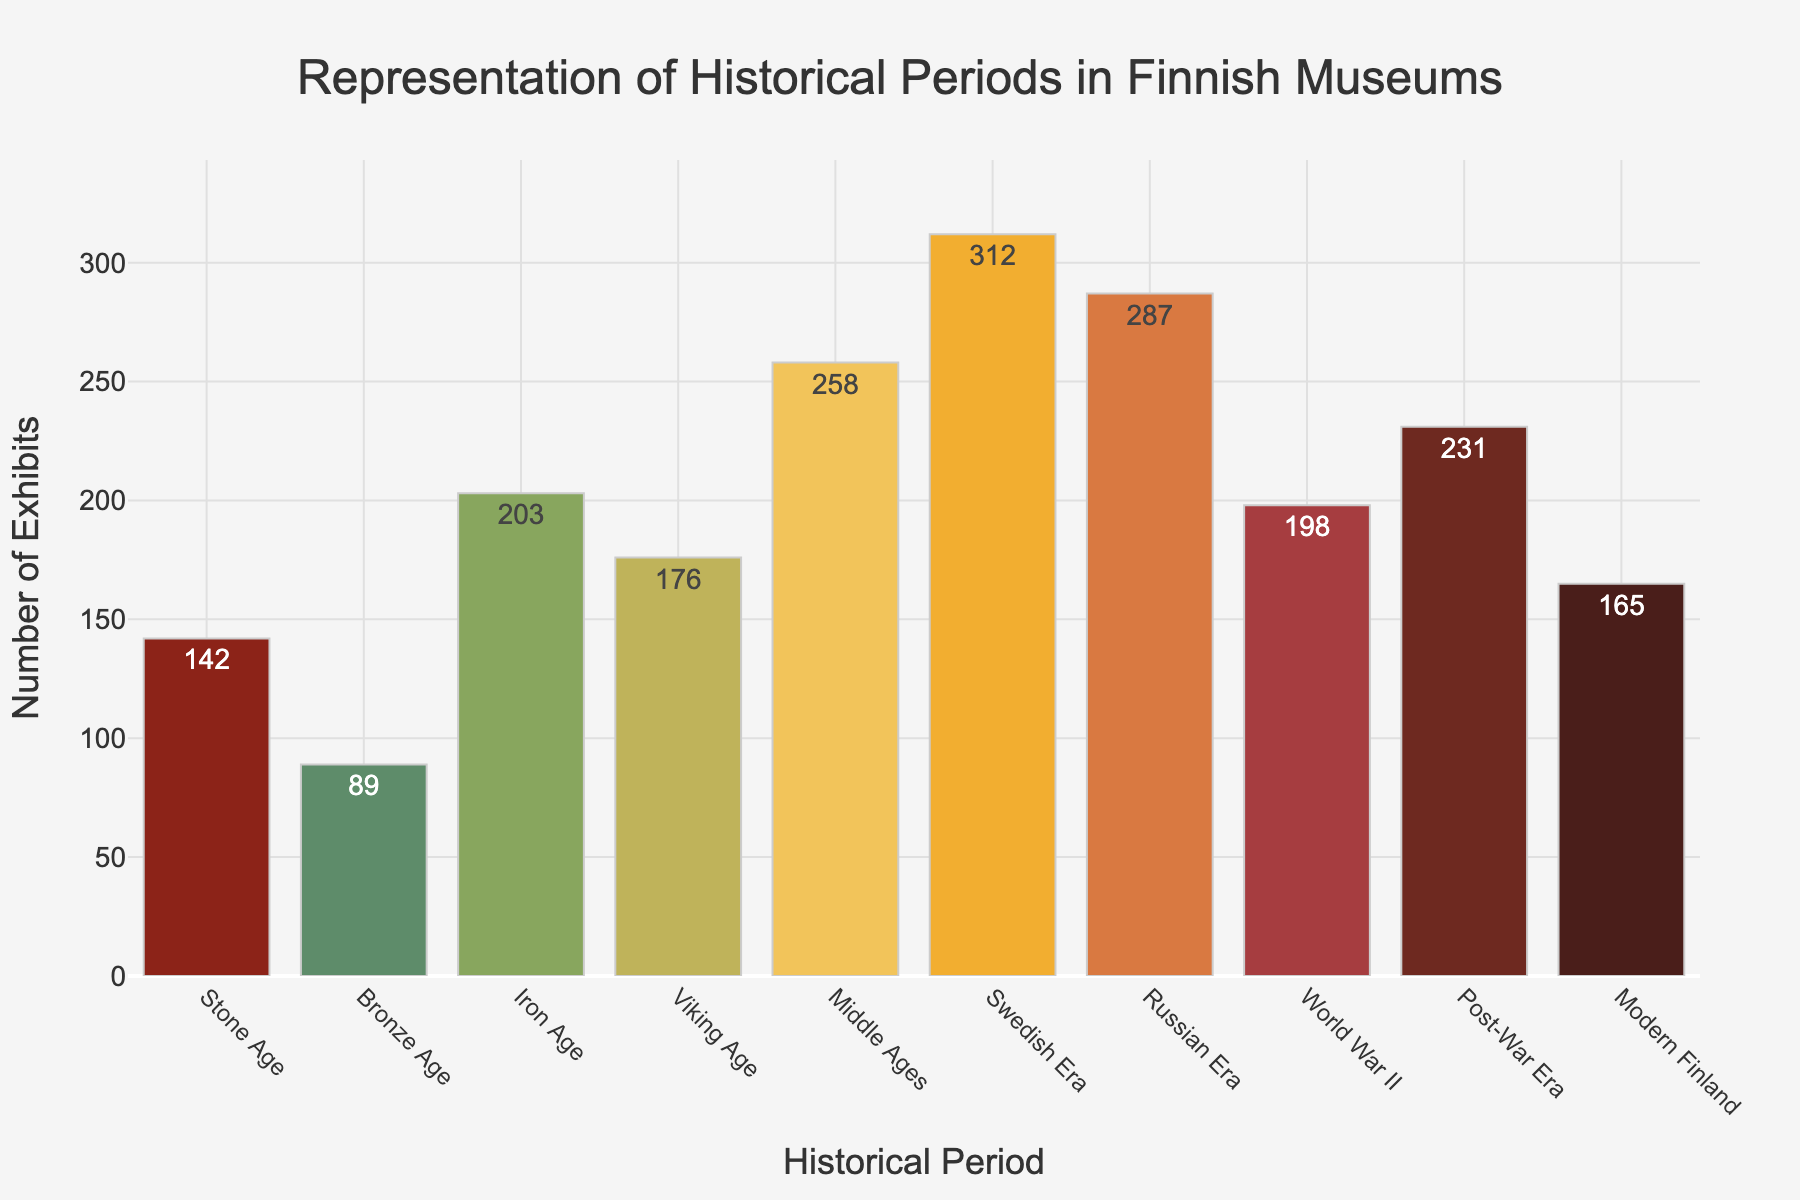Which historical period has the highest number of exhibits? The bar representing the Swedish Era is the tallest in the chart. The number of exhibits is 312.
Answer: Swedish Era Which historical period has the lowest number of exhibits? The bar representing the Bronze Age is the shortest in the chart. The number of exhibits is 89.
Answer: Bronze Age What is the combined number of exhibits from the Medieval Ages and the Viking Age? The number of exhibits for the Middle Ages is 258 and for the Viking Age is 176. Combined, it is 258 + 176 = 434.
Answer: 434 Which period has more exhibits, the Iron Age or Modern Finland? The bar for the Iron Age is taller than the bar for Modern Finland. Iron Age has 203 exhibits, and Modern Finland has 165.
Answer: Iron Age How many more exhibits are there in the Swedish Era compared to the Stone Age? The Swedish Era has 312 exhibits and the Stone Age has 142. The difference is 312 - 142 = 170.
Answer: 170 Which period, the Russian Era or Post-War Era, has a higher number of exhibits, and by how much? The bar for the Russian Era is taller than that for the Post-War Era. Russian Era has 287 exhibits and Post-War Era has 231. The difference is 287 - 231 = 56.
Answer: Russian Era by 56 What is the average number of exhibits across all periods? The total number of exhibits is 142 + 89 + 203 + 176 + 258 + 312 + 287 + 198 + 231 + 165 = 2061. There are 10 periods, so the average is 2061 / 10 = 206.1.
Answer: 206.1 Between World War II and the Post-War Era, which has fewer exhibits and how many fewer? The bar for World War II is shorter than that for the Post-War Era. World War II has 198 exhibits and Post-War Era has 231. The difference is 231 - 198 = 33.
Answer: World War II by 33 Considering the colors used, which period has a green-colored bar? The bar for the Stone Age is green-colored (the first color in the list).
Answer: Stone Age Does the number of exhibits in the Middle Ages fall above or below the average number of exhibits across all periods? The average number of exhibits is 206.1. The Middle Ages have 258 exhibits, which is above the average.
Answer: Above 